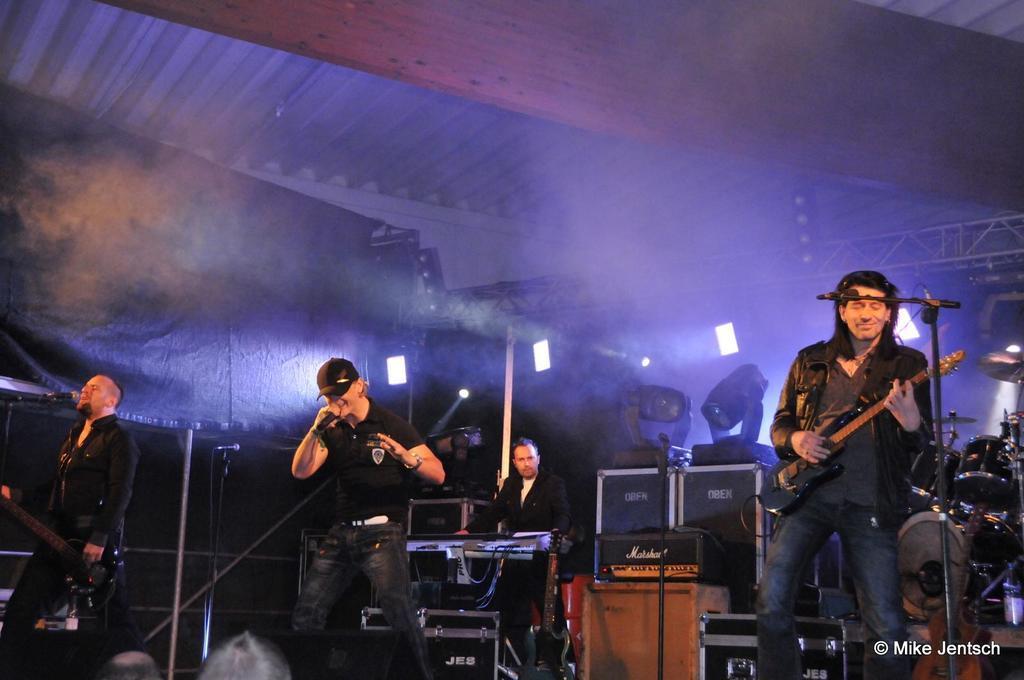Could you give a brief overview of what you see in this image? This picture is clicked in a musical concert. The man in the middle of the picture wearing black t-shirt and black cap is holding a microphone in his hands and singing on it. Beside him, the man on the left corner of the picture wearing black shirt is holding a guitar in his hand and he is singing on the microphone. Man on the right corner of the picture wearing black shirt is holding a guitar in his hand and playing it. In front of him, we see a microphone. Behind him, the man in black shirt is playing keyboard and behind him, we see many musical instruments. 